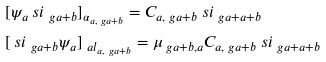<formula> <loc_0><loc_0><loc_500><loc_500>& [ \psi _ { a } \ s i _ { \ g a + b } ] _ { \alpha _ { a , \ g a + b } } = C _ { a , \ g a + b } \ s i _ { \ g a + a + b } \\ & [ \ s i _ { \ g a + b } \psi _ { a } ] _ { \ a l _ { a , \ g a + b } } = \mu _ { \ g a + b , a } C _ { a , \ g a + b } \ s i _ { \ g a + a + b }</formula> 